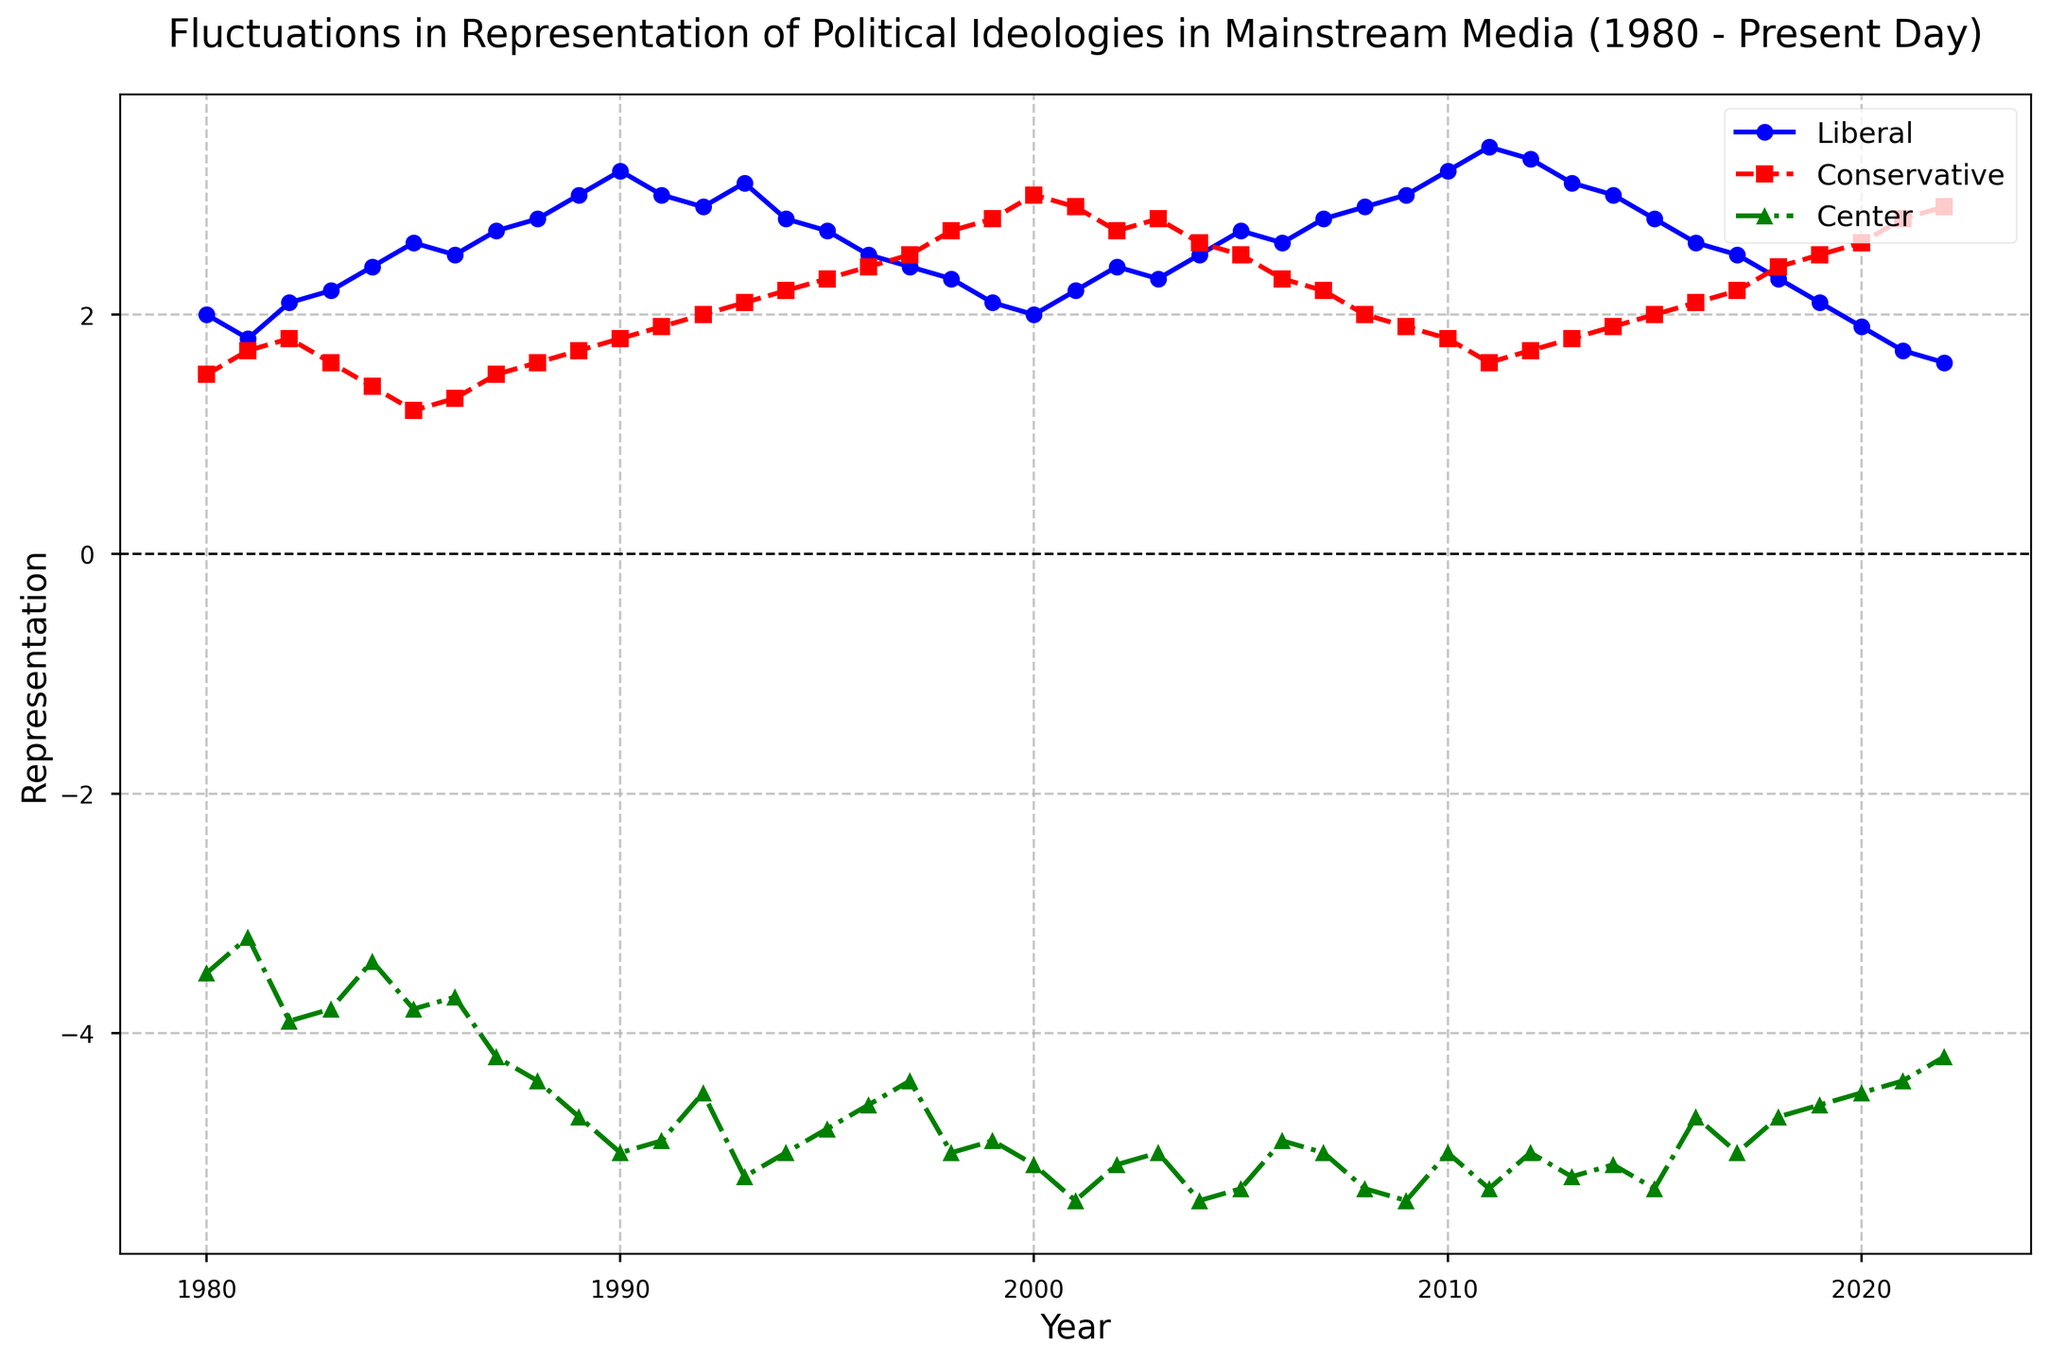What political ideology had the highest representation in 2020? By observing the year 2020 on the x-axis and comparing the values of the Liberal (blue), Conservative (red), and Center (green) lines, it is clear that the Conservative ideology had the highest representation.
Answer: Conservative In which year did the Liberal representation first surpass 3.0? By tracing the blue line for Liberal ideology representation, the first year it surpasses 3.0 is 1989.
Answer: 1989 How did the representation of the Center ideology change from 1985 to 1990? The Center ideology's representation started at -3.8 in 1985 and decreased to -5.0 in 1990. This indicates a decline.
Answer: Declined What is the overall trend of Conservative representation from 2000 to 2010? Examining the red line for Conservative representation from 2000 to 2010, there is an overall declining trend. The values started around 3.0 in 2000 and dropped to about 1.8 in 2010.
Answer: Declining Which year shows the largest gap between Liberal and Conservative representation? By scanning the plot and comparing the gaps between the blue (Liberal) and red (Conservative) lines, the year with the largest gap appears to be 1980.
Answer: 1980 Calculate the average representation of the Liberal ideology between 2010 and 2020. The Liberal ideology values from 2010 to 2020 are: 3.2, 3.4, 3.3, 3.1, 3.0, 2.8, 2.6, 2.5, 2.3, 2.1, 1.9. Sum these values: (3.2 + 3.4 + 3.3 + 3.1 + 3.0 + 2.8 + 2.6 + 2.5 + 2.3 + 2.1 + 1.9) = 29.2. The average is 29.2 / 11 ≈ 2.65.
Answer: 2.65 Compare the representation of the Center ideology in 1998 and 2008. Which year had a higher value? The Center ideology's representation in 1998 is -5.0 and in 2008 it is -5.3. Thus, 1998 had a higher representation.
Answer: 1998 How many years did the Conservative representation stay above 2.5 after 1990? By examining the red line after 1990, the years above 2.5 are 1994, 1995, 1996, 1997, 1998, 1999, 2000, 2001, 2002, 2003, 2004, 2016, 2017, 2018, 2019, 2020, 2021, 2022, making it 18 years.
Answer: 18 In which year did the Liberal and Center ideologies have the closest representation? The closest point between the blue (Liberal) and green (Center) lines seems to be around 1985.
Answer: 1985 